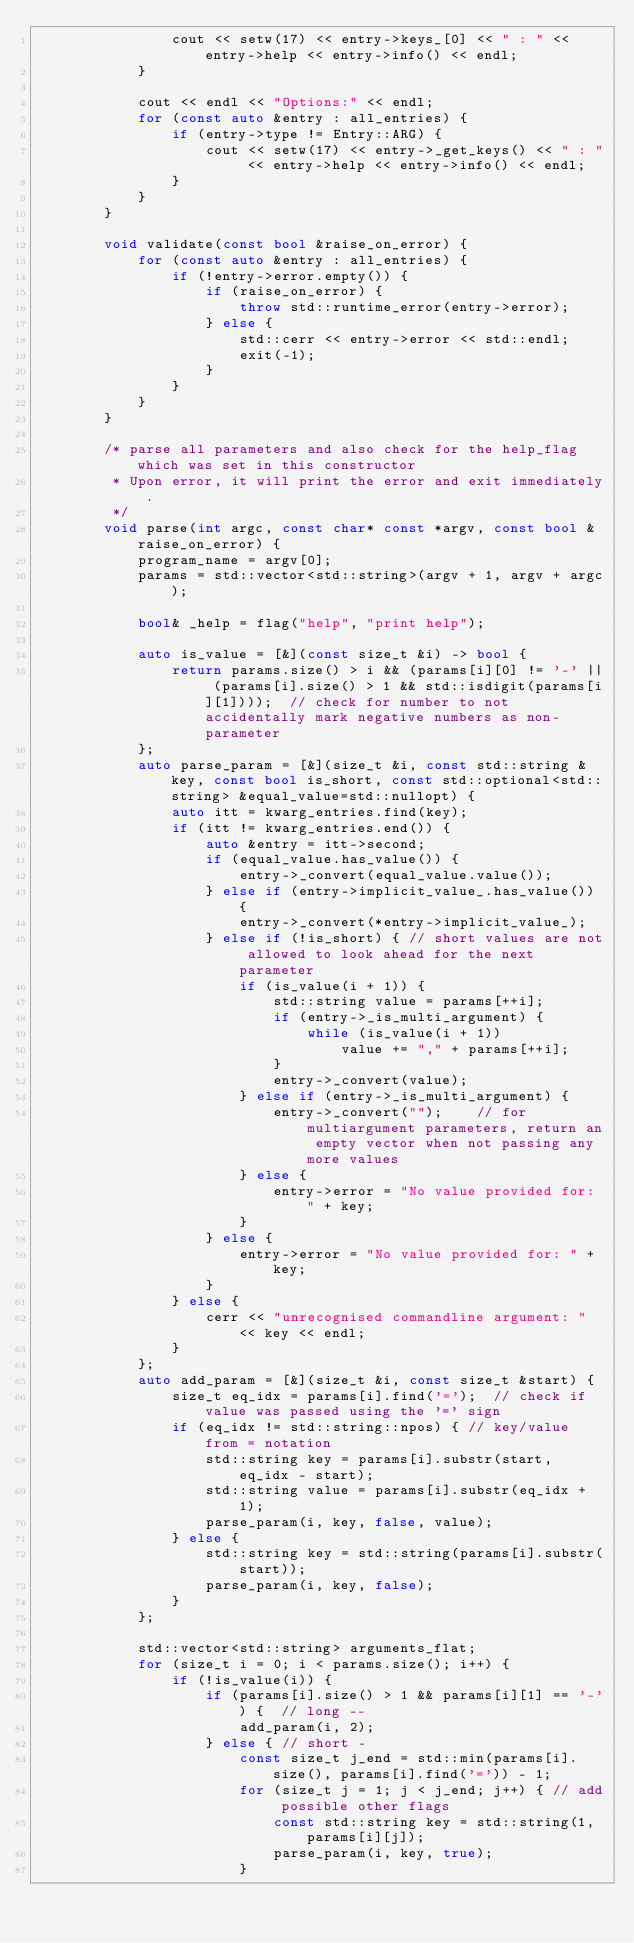<code> <loc_0><loc_0><loc_500><loc_500><_C++_>                cout << setw(17) << entry->keys_[0] << " : " << entry->help << entry->info() << endl;
            }

            cout << endl << "Options:" << endl;
            for (const auto &entry : all_entries) {
                if (entry->type != Entry::ARG) {
                    cout << setw(17) << entry->_get_keys() << " : " << entry->help << entry->info() << endl;
                }
            }
        }

        void validate(const bool &raise_on_error) {
            for (const auto &entry : all_entries) {
                if (!entry->error.empty()) {
                    if (raise_on_error) {
                        throw std::runtime_error(entry->error);
                    } else {
                        std::cerr << entry->error << std::endl;
                        exit(-1);
                    }
                }
            }
        }

        /* parse all parameters and also check for the help_flag which was set in this constructor
         * Upon error, it will print the error and exit immediately.
         */
        void parse(int argc, const char* const *argv, const bool &raise_on_error) {
            program_name = argv[0];
            params = std::vector<std::string>(argv + 1, argv + argc);

            bool& _help = flag("help", "print help");

            auto is_value = [&](const size_t &i) -> bool {
                return params.size() > i && (params[i][0] != '-' || (params[i].size() > 1 && std::isdigit(params[i][1])));  // check for number to not accidentally mark negative numbers as non-parameter
            };
            auto parse_param = [&](size_t &i, const std::string &key, const bool is_short, const std::optional<std::string> &equal_value=std::nullopt) {
                auto itt = kwarg_entries.find(key);
                if (itt != kwarg_entries.end()) {
                    auto &entry = itt->second;
                    if (equal_value.has_value()) {
                        entry->_convert(equal_value.value());
                    } else if (entry->implicit_value_.has_value()) {
                        entry->_convert(*entry->implicit_value_);
                    } else if (!is_short) { // short values are not allowed to look ahead for the next parameter
                        if (is_value(i + 1)) {
                            std::string value = params[++i];
                            if (entry->_is_multi_argument) {
                                while (is_value(i + 1))
                                    value += "," + params[++i];
                            }
                            entry->_convert(value);
                        } else if (entry->_is_multi_argument) {
                            entry->_convert("");    // for multiargument parameters, return an empty vector when not passing any more values
                        } else {
                            entry->error = "No value provided for: " + key;
                        }
                    } else {
                        entry->error = "No value provided for: " + key;
                    }
                } else {
                    cerr << "unrecognised commandline argument: " << key << endl;
                }
            };
            auto add_param = [&](size_t &i, const size_t &start) {
                size_t eq_idx = params[i].find('=');  // check if value was passed using the '=' sign
                if (eq_idx != std::string::npos) { // key/value from = notation
                    std::string key = params[i].substr(start, eq_idx - start);
                    std::string value = params[i].substr(eq_idx + 1);
                    parse_param(i, key, false, value);
                } else {
                    std::string key = std::string(params[i].substr(start));
                    parse_param(i, key, false);
                }
            };

            std::vector<std::string> arguments_flat;
            for (size_t i = 0; i < params.size(); i++) {
                if (!is_value(i)) {
                    if (params[i].size() > 1 && params[i][1] == '-') {  // long --
                        add_param(i, 2);
                    } else { // short -
                        const size_t j_end = std::min(params[i].size(), params[i].find('=')) - 1;
                        for (size_t j = 1; j < j_end; j++) { // add possible other flags
                            const std::string key = std::string(1, params[i][j]);
                            parse_param(i, key, true);
                        }</code> 